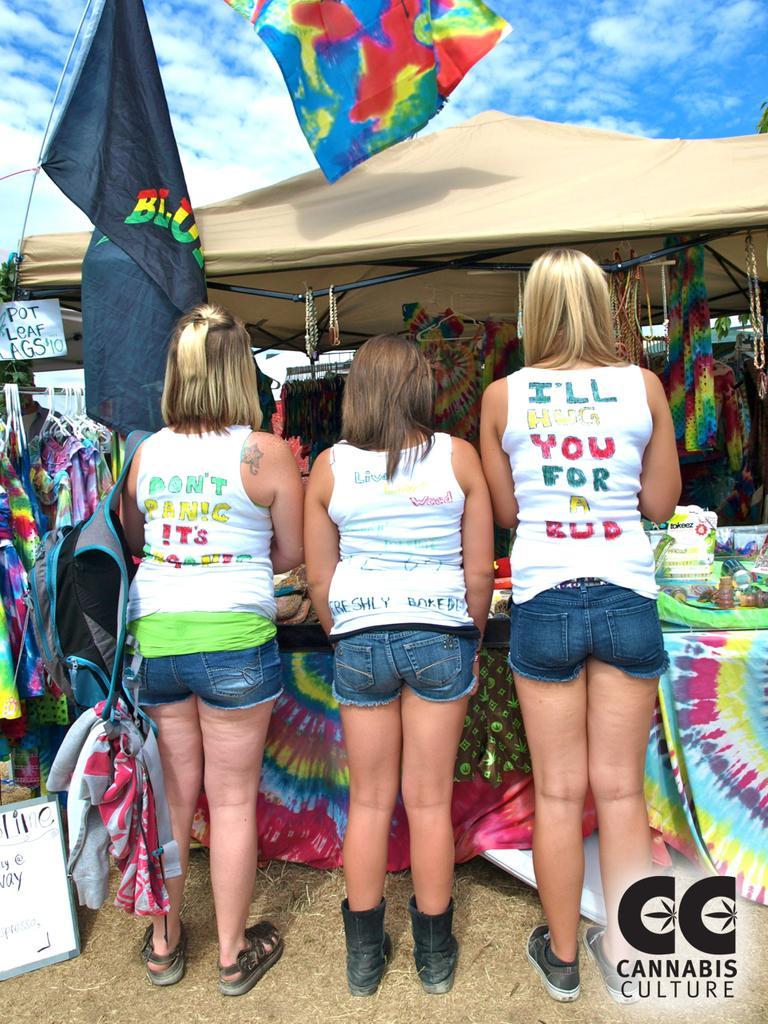Could you give a brief overview of what you see in this image? In this image I can see three people standing in-front of the stall. I can see the tent and many objects are hanged to the tent. I can see few objects on the table. To the left I can see the boards, few colorful clothes and the flags. In the background I can see the clouds and the sky. 